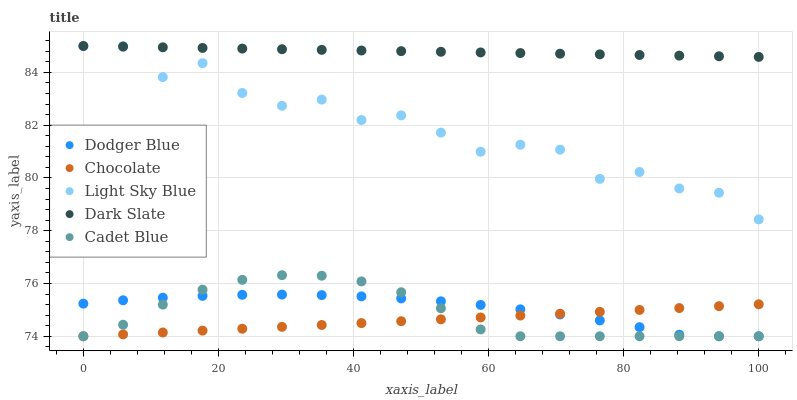Does Chocolate have the minimum area under the curve?
Answer yes or no. Yes. Does Dark Slate have the maximum area under the curve?
Answer yes or no. Yes. Does Light Sky Blue have the minimum area under the curve?
Answer yes or no. No. Does Light Sky Blue have the maximum area under the curve?
Answer yes or no. No. Is Dark Slate the smoothest?
Answer yes or no. Yes. Is Light Sky Blue the roughest?
Answer yes or no. Yes. Is Light Sky Blue the smoothest?
Answer yes or no. No. Is Dark Slate the roughest?
Answer yes or no. No. Does Cadet Blue have the lowest value?
Answer yes or no. Yes. Does Light Sky Blue have the lowest value?
Answer yes or no. No. Does Light Sky Blue have the highest value?
Answer yes or no. Yes. Does Dodger Blue have the highest value?
Answer yes or no. No. Is Dodger Blue less than Light Sky Blue?
Answer yes or no. Yes. Is Light Sky Blue greater than Dodger Blue?
Answer yes or no. Yes. Does Dodger Blue intersect Chocolate?
Answer yes or no. Yes. Is Dodger Blue less than Chocolate?
Answer yes or no. No. Is Dodger Blue greater than Chocolate?
Answer yes or no. No. Does Dodger Blue intersect Light Sky Blue?
Answer yes or no. No. 